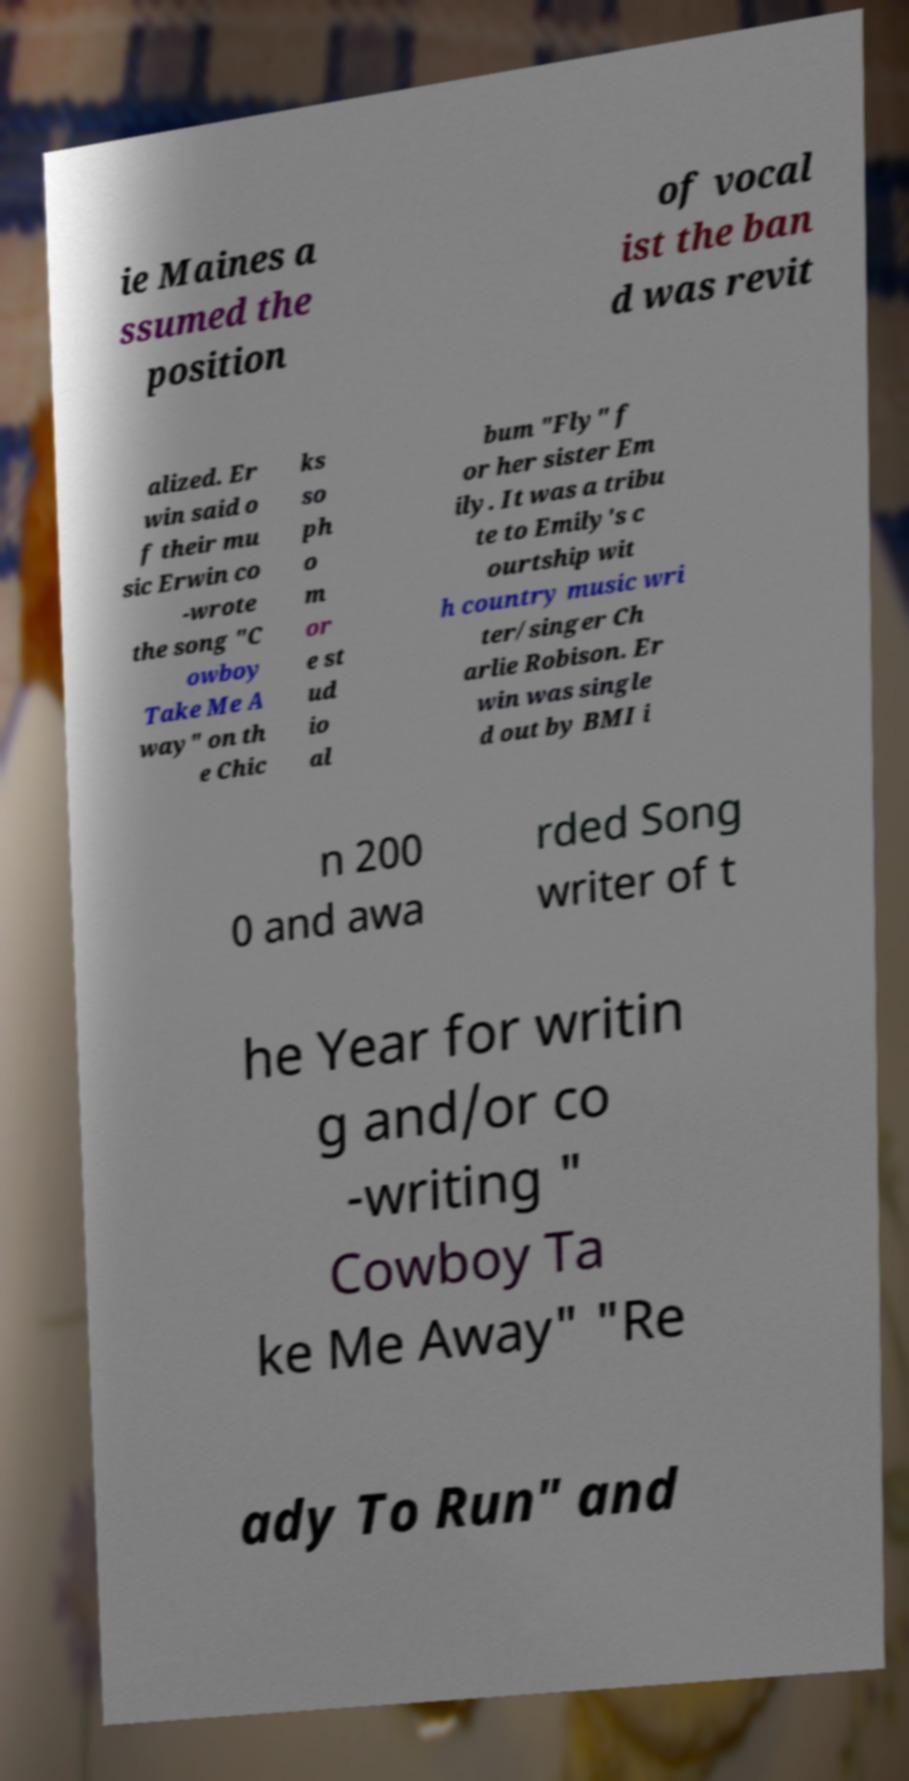For documentation purposes, I need the text within this image transcribed. Could you provide that? ie Maines a ssumed the position of vocal ist the ban d was revit alized. Er win said o f their mu sic Erwin co -wrote the song "C owboy Take Me A way" on th e Chic ks so ph o m or e st ud io al bum "Fly" f or her sister Em ily. It was a tribu te to Emily's c ourtship wit h country music wri ter/singer Ch arlie Robison. Er win was single d out by BMI i n 200 0 and awa rded Song writer of t he Year for writin g and/or co -writing " Cowboy Ta ke Me Away" "Re ady To Run" and 